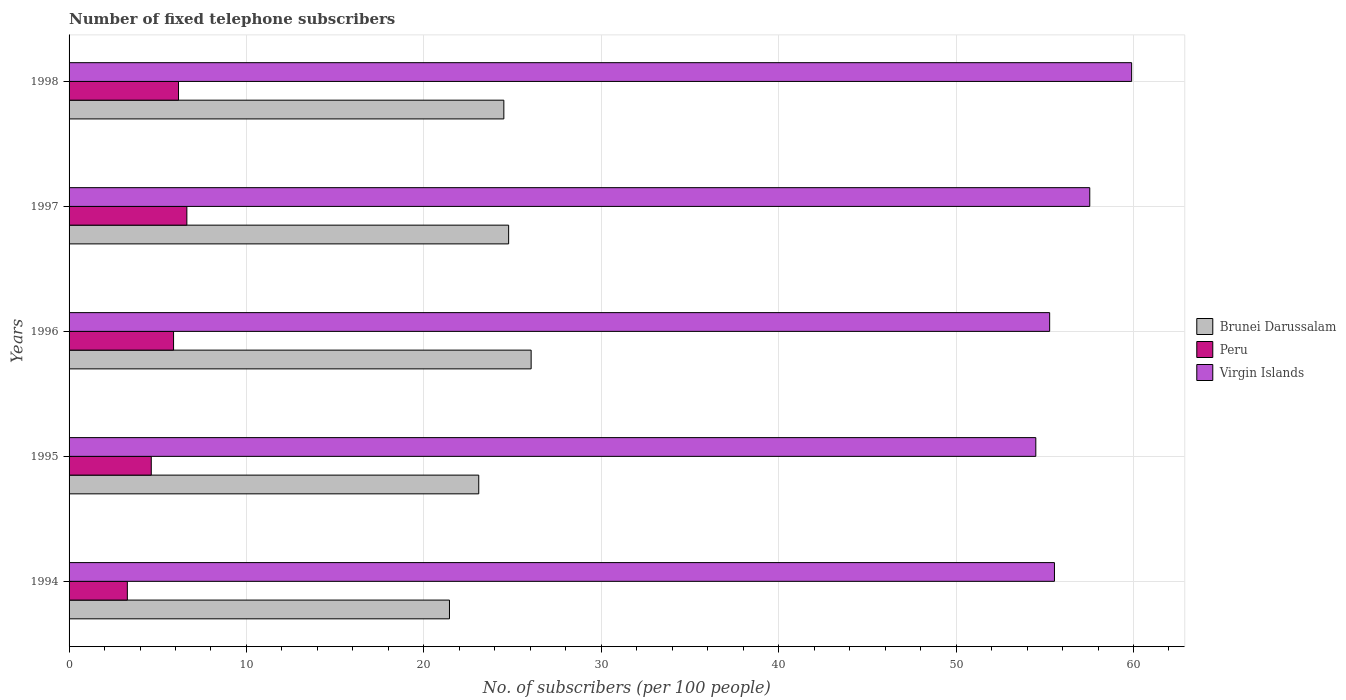How many groups of bars are there?
Provide a succinct answer. 5. Are the number of bars on each tick of the Y-axis equal?
Your answer should be very brief. Yes. How many bars are there on the 4th tick from the top?
Ensure brevity in your answer.  3. What is the number of fixed telephone subscribers in Brunei Darussalam in 1994?
Make the answer very short. 21.44. Across all years, what is the maximum number of fixed telephone subscribers in Brunei Darussalam?
Provide a short and direct response. 26.05. Across all years, what is the minimum number of fixed telephone subscribers in Virgin Islands?
Offer a terse response. 54.49. What is the total number of fixed telephone subscribers in Virgin Islands in the graph?
Offer a very short reply. 282.75. What is the difference between the number of fixed telephone subscribers in Virgin Islands in 1994 and that in 1996?
Your answer should be compact. 0.27. What is the difference between the number of fixed telephone subscribers in Brunei Darussalam in 1994 and the number of fixed telephone subscribers in Virgin Islands in 1998?
Offer a terse response. -38.45. What is the average number of fixed telephone subscribers in Brunei Darussalam per year?
Your response must be concise. 23.97. In the year 1995, what is the difference between the number of fixed telephone subscribers in Peru and number of fixed telephone subscribers in Virgin Islands?
Offer a very short reply. -49.86. In how many years, is the number of fixed telephone subscribers in Peru greater than 58 ?
Give a very brief answer. 0. What is the ratio of the number of fixed telephone subscribers in Peru in 1996 to that in 1997?
Give a very brief answer. 0.89. Is the difference between the number of fixed telephone subscribers in Peru in 1994 and 1996 greater than the difference between the number of fixed telephone subscribers in Virgin Islands in 1994 and 1996?
Offer a terse response. No. What is the difference between the highest and the second highest number of fixed telephone subscribers in Peru?
Offer a very short reply. 0.47. What is the difference between the highest and the lowest number of fixed telephone subscribers in Virgin Islands?
Offer a very short reply. 5.4. Is the sum of the number of fixed telephone subscribers in Brunei Darussalam in 1994 and 1997 greater than the maximum number of fixed telephone subscribers in Virgin Islands across all years?
Offer a very short reply. No. What does the 3rd bar from the top in 1995 represents?
Provide a short and direct response. Brunei Darussalam. What does the 1st bar from the bottom in 1994 represents?
Offer a terse response. Brunei Darussalam. How many bars are there?
Your answer should be very brief. 15. How many years are there in the graph?
Provide a succinct answer. 5. What is the difference between two consecutive major ticks on the X-axis?
Your answer should be compact. 10. Does the graph contain any zero values?
Offer a terse response. No. Does the graph contain grids?
Offer a terse response. Yes. Where does the legend appear in the graph?
Provide a succinct answer. Center right. How are the legend labels stacked?
Give a very brief answer. Vertical. What is the title of the graph?
Your answer should be compact. Number of fixed telephone subscribers. Does "Nigeria" appear as one of the legend labels in the graph?
Give a very brief answer. No. What is the label or title of the X-axis?
Your response must be concise. No. of subscribers (per 100 people). What is the No. of subscribers (per 100 people) of Brunei Darussalam in 1994?
Offer a very short reply. 21.44. What is the No. of subscribers (per 100 people) in Peru in 1994?
Provide a short and direct response. 3.29. What is the No. of subscribers (per 100 people) of Virgin Islands in 1994?
Provide a short and direct response. 55.55. What is the No. of subscribers (per 100 people) of Brunei Darussalam in 1995?
Provide a succinct answer. 23.09. What is the No. of subscribers (per 100 people) in Peru in 1995?
Your response must be concise. 4.63. What is the No. of subscribers (per 100 people) in Virgin Islands in 1995?
Provide a short and direct response. 54.49. What is the No. of subscribers (per 100 people) of Brunei Darussalam in 1996?
Offer a very short reply. 26.05. What is the No. of subscribers (per 100 people) in Peru in 1996?
Give a very brief answer. 5.89. What is the No. of subscribers (per 100 people) in Virgin Islands in 1996?
Provide a succinct answer. 55.28. What is the No. of subscribers (per 100 people) in Brunei Darussalam in 1997?
Offer a terse response. 24.78. What is the No. of subscribers (per 100 people) of Peru in 1997?
Offer a very short reply. 6.64. What is the No. of subscribers (per 100 people) in Virgin Islands in 1997?
Your answer should be very brief. 57.54. What is the No. of subscribers (per 100 people) in Brunei Darussalam in 1998?
Provide a succinct answer. 24.51. What is the No. of subscribers (per 100 people) of Peru in 1998?
Ensure brevity in your answer.  6.17. What is the No. of subscribers (per 100 people) in Virgin Islands in 1998?
Your answer should be compact. 59.9. Across all years, what is the maximum No. of subscribers (per 100 people) in Brunei Darussalam?
Your answer should be compact. 26.05. Across all years, what is the maximum No. of subscribers (per 100 people) of Peru?
Your answer should be compact. 6.64. Across all years, what is the maximum No. of subscribers (per 100 people) in Virgin Islands?
Offer a very short reply. 59.9. Across all years, what is the minimum No. of subscribers (per 100 people) in Brunei Darussalam?
Give a very brief answer. 21.44. Across all years, what is the minimum No. of subscribers (per 100 people) in Peru?
Make the answer very short. 3.29. Across all years, what is the minimum No. of subscribers (per 100 people) of Virgin Islands?
Offer a very short reply. 54.49. What is the total No. of subscribers (per 100 people) in Brunei Darussalam in the graph?
Your answer should be compact. 119.87. What is the total No. of subscribers (per 100 people) of Peru in the graph?
Your answer should be compact. 26.62. What is the total No. of subscribers (per 100 people) of Virgin Islands in the graph?
Your answer should be compact. 282.75. What is the difference between the No. of subscribers (per 100 people) of Brunei Darussalam in 1994 and that in 1995?
Offer a terse response. -1.65. What is the difference between the No. of subscribers (per 100 people) of Peru in 1994 and that in 1995?
Ensure brevity in your answer.  -1.35. What is the difference between the No. of subscribers (per 100 people) in Virgin Islands in 1994 and that in 1995?
Offer a very short reply. 1.05. What is the difference between the No. of subscribers (per 100 people) in Brunei Darussalam in 1994 and that in 1996?
Make the answer very short. -4.6. What is the difference between the No. of subscribers (per 100 people) of Peru in 1994 and that in 1996?
Offer a very short reply. -2.6. What is the difference between the No. of subscribers (per 100 people) in Virgin Islands in 1994 and that in 1996?
Provide a succinct answer. 0.27. What is the difference between the No. of subscribers (per 100 people) of Brunei Darussalam in 1994 and that in 1997?
Your answer should be very brief. -3.34. What is the difference between the No. of subscribers (per 100 people) in Peru in 1994 and that in 1997?
Give a very brief answer. -3.35. What is the difference between the No. of subscribers (per 100 people) of Virgin Islands in 1994 and that in 1997?
Offer a very short reply. -1.99. What is the difference between the No. of subscribers (per 100 people) of Brunei Darussalam in 1994 and that in 1998?
Ensure brevity in your answer.  -3.06. What is the difference between the No. of subscribers (per 100 people) of Peru in 1994 and that in 1998?
Give a very brief answer. -2.88. What is the difference between the No. of subscribers (per 100 people) in Virgin Islands in 1994 and that in 1998?
Your answer should be compact. -4.35. What is the difference between the No. of subscribers (per 100 people) in Brunei Darussalam in 1995 and that in 1996?
Your response must be concise. -2.95. What is the difference between the No. of subscribers (per 100 people) in Peru in 1995 and that in 1996?
Keep it short and to the point. -1.26. What is the difference between the No. of subscribers (per 100 people) of Virgin Islands in 1995 and that in 1996?
Your answer should be compact. -0.78. What is the difference between the No. of subscribers (per 100 people) in Brunei Darussalam in 1995 and that in 1997?
Offer a terse response. -1.68. What is the difference between the No. of subscribers (per 100 people) of Peru in 1995 and that in 1997?
Provide a succinct answer. -2.01. What is the difference between the No. of subscribers (per 100 people) of Virgin Islands in 1995 and that in 1997?
Offer a very short reply. -3.04. What is the difference between the No. of subscribers (per 100 people) of Brunei Darussalam in 1995 and that in 1998?
Your answer should be very brief. -1.41. What is the difference between the No. of subscribers (per 100 people) of Peru in 1995 and that in 1998?
Provide a succinct answer. -1.54. What is the difference between the No. of subscribers (per 100 people) of Virgin Islands in 1995 and that in 1998?
Offer a very short reply. -5.4. What is the difference between the No. of subscribers (per 100 people) of Brunei Darussalam in 1996 and that in 1997?
Make the answer very short. 1.27. What is the difference between the No. of subscribers (per 100 people) of Peru in 1996 and that in 1997?
Offer a terse response. -0.75. What is the difference between the No. of subscribers (per 100 people) in Virgin Islands in 1996 and that in 1997?
Ensure brevity in your answer.  -2.26. What is the difference between the No. of subscribers (per 100 people) in Brunei Darussalam in 1996 and that in 1998?
Offer a very short reply. 1.54. What is the difference between the No. of subscribers (per 100 people) of Peru in 1996 and that in 1998?
Give a very brief answer. -0.28. What is the difference between the No. of subscribers (per 100 people) in Virgin Islands in 1996 and that in 1998?
Provide a short and direct response. -4.62. What is the difference between the No. of subscribers (per 100 people) in Brunei Darussalam in 1997 and that in 1998?
Your response must be concise. 0.27. What is the difference between the No. of subscribers (per 100 people) of Peru in 1997 and that in 1998?
Your answer should be compact. 0.47. What is the difference between the No. of subscribers (per 100 people) of Virgin Islands in 1997 and that in 1998?
Your response must be concise. -2.36. What is the difference between the No. of subscribers (per 100 people) in Brunei Darussalam in 1994 and the No. of subscribers (per 100 people) in Peru in 1995?
Ensure brevity in your answer.  16.81. What is the difference between the No. of subscribers (per 100 people) of Brunei Darussalam in 1994 and the No. of subscribers (per 100 people) of Virgin Islands in 1995?
Give a very brief answer. -33.05. What is the difference between the No. of subscribers (per 100 people) in Peru in 1994 and the No. of subscribers (per 100 people) in Virgin Islands in 1995?
Your response must be concise. -51.21. What is the difference between the No. of subscribers (per 100 people) of Brunei Darussalam in 1994 and the No. of subscribers (per 100 people) of Peru in 1996?
Ensure brevity in your answer.  15.55. What is the difference between the No. of subscribers (per 100 people) of Brunei Darussalam in 1994 and the No. of subscribers (per 100 people) of Virgin Islands in 1996?
Make the answer very short. -33.83. What is the difference between the No. of subscribers (per 100 people) in Peru in 1994 and the No. of subscribers (per 100 people) in Virgin Islands in 1996?
Your answer should be very brief. -51.99. What is the difference between the No. of subscribers (per 100 people) in Brunei Darussalam in 1994 and the No. of subscribers (per 100 people) in Peru in 1997?
Your answer should be very brief. 14.8. What is the difference between the No. of subscribers (per 100 people) of Brunei Darussalam in 1994 and the No. of subscribers (per 100 people) of Virgin Islands in 1997?
Offer a very short reply. -36.09. What is the difference between the No. of subscribers (per 100 people) in Peru in 1994 and the No. of subscribers (per 100 people) in Virgin Islands in 1997?
Offer a terse response. -54.25. What is the difference between the No. of subscribers (per 100 people) in Brunei Darussalam in 1994 and the No. of subscribers (per 100 people) in Peru in 1998?
Keep it short and to the point. 15.27. What is the difference between the No. of subscribers (per 100 people) of Brunei Darussalam in 1994 and the No. of subscribers (per 100 people) of Virgin Islands in 1998?
Your answer should be very brief. -38.45. What is the difference between the No. of subscribers (per 100 people) in Peru in 1994 and the No. of subscribers (per 100 people) in Virgin Islands in 1998?
Offer a very short reply. -56.61. What is the difference between the No. of subscribers (per 100 people) in Brunei Darussalam in 1995 and the No. of subscribers (per 100 people) in Peru in 1996?
Give a very brief answer. 17.2. What is the difference between the No. of subscribers (per 100 people) of Brunei Darussalam in 1995 and the No. of subscribers (per 100 people) of Virgin Islands in 1996?
Ensure brevity in your answer.  -32.18. What is the difference between the No. of subscribers (per 100 people) in Peru in 1995 and the No. of subscribers (per 100 people) in Virgin Islands in 1996?
Provide a succinct answer. -50.64. What is the difference between the No. of subscribers (per 100 people) in Brunei Darussalam in 1995 and the No. of subscribers (per 100 people) in Peru in 1997?
Make the answer very short. 16.45. What is the difference between the No. of subscribers (per 100 people) of Brunei Darussalam in 1995 and the No. of subscribers (per 100 people) of Virgin Islands in 1997?
Make the answer very short. -34.44. What is the difference between the No. of subscribers (per 100 people) of Peru in 1995 and the No. of subscribers (per 100 people) of Virgin Islands in 1997?
Your answer should be compact. -52.9. What is the difference between the No. of subscribers (per 100 people) of Brunei Darussalam in 1995 and the No. of subscribers (per 100 people) of Peru in 1998?
Your answer should be very brief. 16.92. What is the difference between the No. of subscribers (per 100 people) in Brunei Darussalam in 1995 and the No. of subscribers (per 100 people) in Virgin Islands in 1998?
Offer a terse response. -36.8. What is the difference between the No. of subscribers (per 100 people) of Peru in 1995 and the No. of subscribers (per 100 people) of Virgin Islands in 1998?
Offer a terse response. -55.26. What is the difference between the No. of subscribers (per 100 people) of Brunei Darussalam in 1996 and the No. of subscribers (per 100 people) of Peru in 1997?
Your response must be concise. 19.41. What is the difference between the No. of subscribers (per 100 people) of Brunei Darussalam in 1996 and the No. of subscribers (per 100 people) of Virgin Islands in 1997?
Provide a succinct answer. -31.49. What is the difference between the No. of subscribers (per 100 people) of Peru in 1996 and the No. of subscribers (per 100 people) of Virgin Islands in 1997?
Your answer should be very brief. -51.65. What is the difference between the No. of subscribers (per 100 people) in Brunei Darussalam in 1996 and the No. of subscribers (per 100 people) in Peru in 1998?
Ensure brevity in your answer.  19.88. What is the difference between the No. of subscribers (per 100 people) of Brunei Darussalam in 1996 and the No. of subscribers (per 100 people) of Virgin Islands in 1998?
Your answer should be compact. -33.85. What is the difference between the No. of subscribers (per 100 people) of Peru in 1996 and the No. of subscribers (per 100 people) of Virgin Islands in 1998?
Provide a succinct answer. -54.01. What is the difference between the No. of subscribers (per 100 people) in Brunei Darussalam in 1997 and the No. of subscribers (per 100 people) in Peru in 1998?
Offer a terse response. 18.61. What is the difference between the No. of subscribers (per 100 people) of Brunei Darussalam in 1997 and the No. of subscribers (per 100 people) of Virgin Islands in 1998?
Provide a succinct answer. -35.12. What is the difference between the No. of subscribers (per 100 people) of Peru in 1997 and the No. of subscribers (per 100 people) of Virgin Islands in 1998?
Offer a very short reply. -53.26. What is the average No. of subscribers (per 100 people) in Brunei Darussalam per year?
Your answer should be very brief. 23.97. What is the average No. of subscribers (per 100 people) of Peru per year?
Offer a terse response. 5.32. What is the average No. of subscribers (per 100 people) of Virgin Islands per year?
Ensure brevity in your answer.  56.55. In the year 1994, what is the difference between the No. of subscribers (per 100 people) in Brunei Darussalam and No. of subscribers (per 100 people) in Peru?
Offer a very short reply. 18.16. In the year 1994, what is the difference between the No. of subscribers (per 100 people) in Brunei Darussalam and No. of subscribers (per 100 people) in Virgin Islands?
Your answer should be very brief. -34.1. In the year 1994, what is the difference between the No. of subscribers (per 100 people) of Peru and No. of subscribers (per 100 people) of Virgin Islands?
Offer a very short reply. -52.26. In the year 1995, what is the difference between the No. of subscribers (per 100 people) in Brunei Darussalam and No. of subscribers (per 100 people) in Peru?
Your answer should be compact. 18.46. In the year 1995, what is the difference between the No. of subscribers (per 100 people) of Brunei Darussalam and No. of subscribers (per 100 people) of Virgin Islands?
Your answer should be compact. -31.4. In the year 1995, what is the difference between the No. of subscribers (per 100 people) of Peru and No. of subscribers (per 100 people) of Virgin Islands?
Provide a short and direct response. -49.86. In the year 1996, what is the difference between the No. of subscribers (per 100 people) in Brunei Darussalam and No. of subscribers (per 100 people) in Peru?
Provide a succinct answer. 20.16. In the year 1996, what is the difference between the No. of subscribers (per 100 people) of Brunei Darussalam and No. of subscribers (per 100 people) of Virgin Islands?
Provide a short and direct response. -29.23. In the year 1996, what is the difference between the No. of subscribers (per 100 people) of Peru and No. of subscribers (per 100 people) of Virgin Islands?
Your answer should be compact. -49.39. In the year 1997, what is the difference between the No. of subscribers (per 100 people) in Brunei Darussalam and No. of subscribers (per 100 people) in Peru?
Offer a very short reply. 18.14. In the year 1997, what is the difference between the No. of subscribers (per 100 people) in Brunei Darussalam and No. of subscribers (per 100 people) in Virgin Islands?
Offer a terse response. -32.76. In the year 1997, what is the difference between the No. of subscribers (per 100 people) of Peru and No. of subscribers (per 100 people) of Virgin Islands?
Ensure brevity in your answer.  -50.9. In the year 1998, what is the difference between the No. of subscribers (per 100 people) of Brunei Darussalam and No. of subscribers (per 100 people) of Peru?
Keep it short and to the point. 18.34. In the year 1998, what is the difference between the No. of subscribers (per 100 people) in Brunei Darussalam and No. of subscribers (per 100 people) in Virgin Islands?
Offer a terse response. -35.39. In the year 1998, what is the difference between the No. of subscribers (per 100 people) in Peru and No. of subscribers (per 100 people) in Virgin Islands?
Ensure brevity in your answer.  -53.73. What is the ratio of the No. of subscribers (per 100 people) in Brunei Darussalam in 1994 to that in 1995?
Your answer should be very brief. 0.93. What is the ratio of the No. of subscribers (per 100 people) in Peru in 1994 to that in 1995?
Provide a short and direct response. 0.71. What is the ratio of the No. of subscribers (per 100 people) in Virgin Islands in 1994 to that in 1995?
Provide a short and direct response. 1.02. What is the ratio of the No. of subscribers (per 100 people) in Brunei Darussalam in 1994 to that in 1996?
Offer a terse response. 0.82. What is the ratio of the No. of subscribers (per 100 people) in Peru in 1994 to that in 1996?
Ensure brevity in your answer.  0.56. What is the ratio of the No. of subscribers (per 100 people) of Virgin Islands in 1994 to that in 1996?
Offer a terse response. 1. What is the ratio of the No. of subscribers (per 100 people) of Brunei Darussalam in 1994 to that in 1997?
Make the answer very short. 0.87. What is the ratio of the No. of subscribers (per 100 people) of Peru in 1994 to that in 1997?
Your response must be concise. 0.49. What is the ratio of the No. of subscribers (per 100 people) in Virgin Islands in 1994 to that in 1997?
Provide a succinct answer. 0.97. What is the ratio of the No. of subscribers (per 100 people) of Brunei Darussalam in 1994 to that in 1998?
Your response must be concise. 0.87. What is the ratio of the No. of subscribers (per 100 people) of Peru in 1994 to that in 1998?
Offer a very short reply. 0.53. What is the ratio of the No. of subscribers (per 100 people) in Virgin Islands in 1994 to that in 1998?
Your response must be concise. 0.93. What is the ratio of the No. of subscribers (per 100 people) of Brunei Darussalam in 1995 to that in 1996?
Give a very brief answer. 0.89. What is the ratio of the No. of subscribers (per 100 people) in Peru in 1995 to that in 1996?
Offer a very short reply. 0.79. What is the ratio of the No. of subscribers (per 100 people) in Virgin Islands in 1995 to that in 1996?
Provide a short and direct response. 0.99. What is the ratio of the No. of subscribers (per 100 people) in Brunei Darussalam in 1995 to that in 1997?
Provide a succinct answer. 0.93. What is the ratio of the No. of subscribers (per 100 people) of Peru in 1995 to that in 1997?
Provide a short and direct response. 0.7. What is the ratio of the No. of subscribers (per 100 people) in Virgin Islands in 1995 to that in 1997?
Provide a succinct answer. 0.95. What is the ratio of the No. of subscribers (per 100 people) of Brunei Darussalam in 1995 to that in 1998?
Make the answer very short. 0.94. What is the ratio of the No. of subscribers (per 100 people) in Peru in 1995 to that in 1998?
Offer a very short reply. 0.75. What is the ratio of the No. of subscribers (per 100 people) of Virgin Islands in 1995 to that in 1998?
Your answer should be compact. 0.91. What is the ratio of the No. of subscribers (per 100 people) in Brunei Darussalam in 1996 to that in 1997?
Offer a terse response. 1.05. What is the ratio of the No. of subscribers (per 100 people) in Peru in 1996 to that in 1997?
Offer a terse response. 0.89. What is the ratio of the No. of subscribers (per 100 people) in Virgin Islands in 1996 to that in 1997?
Offer a very short reply. 0.96. What is the ratio of the No. of subscribers (per 100 people) in Brunei Darussalam in 1996 to that in 1998?
Your answer should be very brief. 1.06. What is the ratio of the No. of subscribers (per 100 people) in Peru in 1996 to that in 1998?
Your answer should be compact. 0.95. What is the ratio of the No. of subscribers (per 100 people) of Virgin Islands in 1996 to that in 1998?
Make the answer very short. 0.92. What is the ratio of the No. of subscribers (per 100 people) of Peru in 1997 to that in 1998?
Your answer should be compact. 1.08. What is the ratio of the No. of subscribers (per 100 people) of Virgin Islands in 1997 to that in 1998?
Provide a succinct answer. 0.96. What is the difference between the highest and the second highest No. of subscribers (per 100 people) in Brunei Darussalam?
Your answer should be very brief. 1.27. What is the difference between the highest and the second highest No. of subscribers (per 100 people) in Peru?
Provide a succinct answer. 0.47. What is the difference between the highest and the second highest No. of subscribers (per 100 people) of Virgin Islands?
Your answer should be compact. 2.36. What is the difference between the highest and the lowest No. of subscribers (per 100 people) in Brunei Darussalam?
Offer a very short reply. 4.6. What is the difference between the highest and the lowest No. of subscribers (per 100 people) in Peru?
Offer a terse response. 3.35. What is the difference between the highest and the lowest No. of subscribers (per 100 people) in Virgin Islands?
Give a very brief answer. 5.4. 